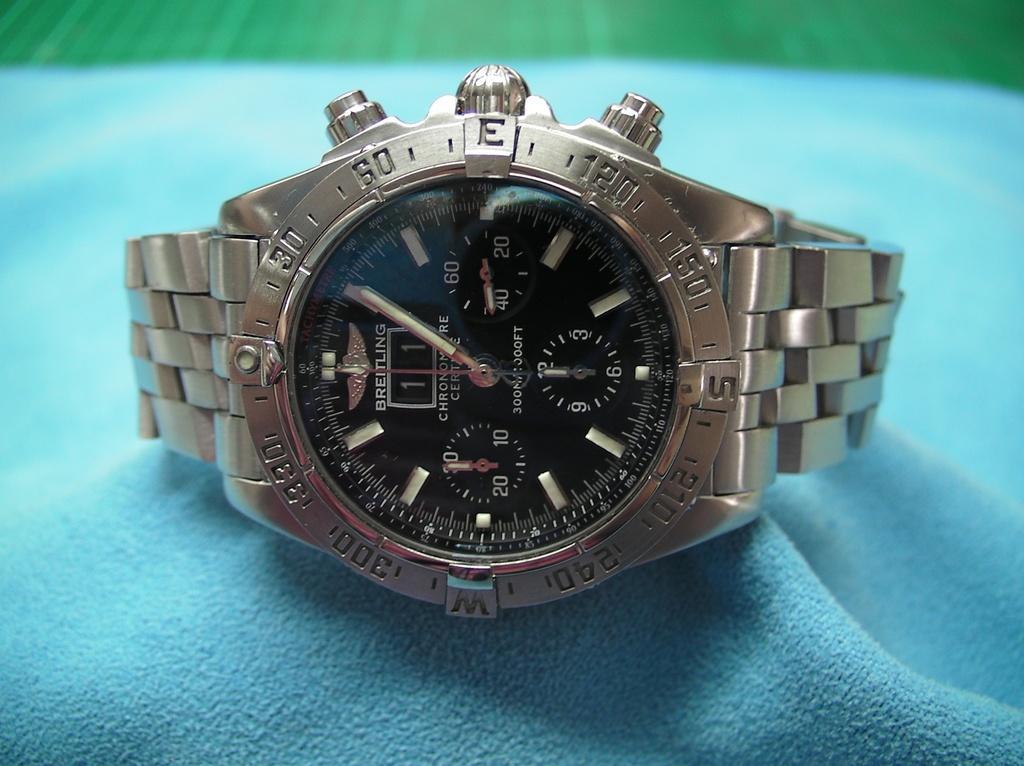How would you summarize this image in a sentence or two? In this image we can see a watch on the blue surface, it is in silver color. 